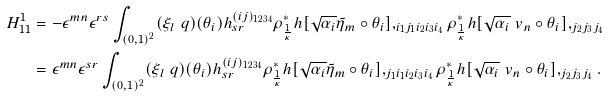<formula> <loc_0><loc_0><loc_500><loc_500>H _ { 1 1 } ^ { 1 } & = - \epsilon ^ { m n } \epsilon ^ { r s } \int _ { ( 0 , 1 ) ^ { 2 } } ( \xi _ { l } \ q ) ( \theta _ { i } ) h _ { s r } ^ { ( i j ) _ { 1 2 3 4 } } \rho _ { \frac { 1 } { \kappa } } ^ { * } h [ \sqrt { \alpha _ { i } } \tilde { \eta } _ { m } \circ \theta _ { i } ] , _ { i _ { 1 } j _ { 1 } i _ { 2 } i _ { 3 } i _ { 4 } } \rho _ { \frac { 1 } { \kappa } } ^ { * } h [ \sqrt { \alpha _ { i } } \ v _ { n } \circ \theta _ { i } ] , _ { j _ { 2 } j _ { 3 } j _ { 4 } } \\ & = \epsilon ^ { m n } \epsilon ^ { s r } \int _ { ( 0 , 1 ) ^ { 2 } } ( \xi _ { l } \ q ) ( \theta _ { i } ) h _ { s r } ^ { ( i j ) _ { 1 2 3 4 } } \rho _ { \frac { 1 } { \kappa } } ^ { * } h [ \sqrt { \alpha _ { i } } \tilde { \eta } _ { m } \circ \theta _ { i } ] , _ { j _ { 1 } i _ { 1 } i _ { 2 } i _ { 3 } i _ { 4 } } \rho _ { \frac { 1 } { \kappa } } ^ { * } h [ \sqrt { \alpha _ { i } } \ v _ { n } \circ \theta _ { i } ] , _ { j _ { 2 } j _ { 3 } j _ { 4 } } .</formula> 